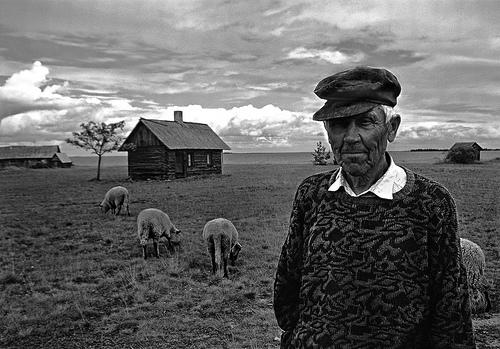What is the house made of?
Be succinct. Wood. Is this a young man?
Give a very brief answer. No. Is this the depiction of an easy life?
Be succinct. No. 